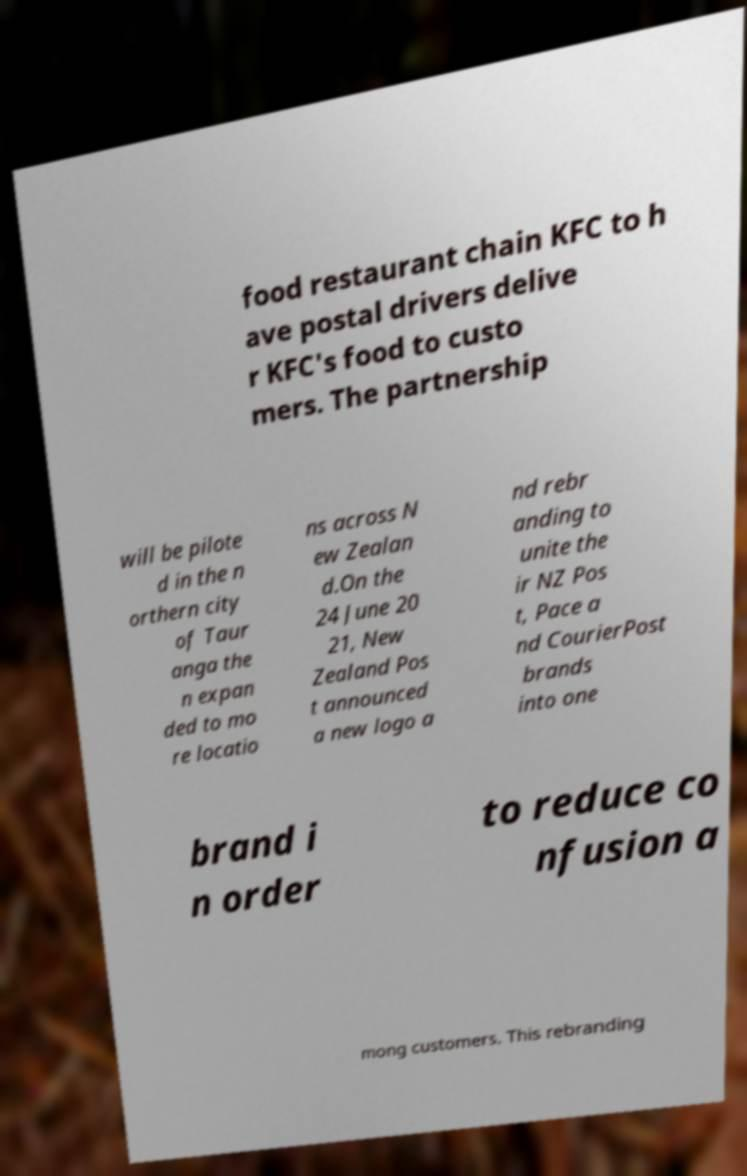For documentation purposes, I need the text within this image transcribed. Could you provide that? food restaurant chain KFC to h ave postal drivers delive r KFC's food to custo mers. The partnership will be pilote d in the n orthern city of Taur anga the n expan ded to mo re locatio ns across N ew Zealan d.On the 24 June 20 21, New Zealand Pos t announced a new logo a nd rebr anding to unite the ir NZ Pos t, Pace a nd CourierPost brands into one brand i n order to reduce co nfusion a mong customers. This rebranding 